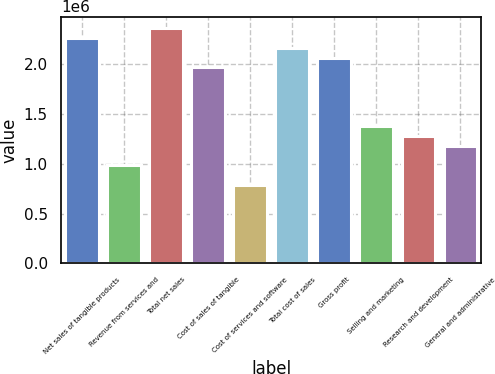<chart> <loc_0><loc_0><loc_500><loc_500><bar_chart><fcel>Net sales of tangible products<fcel>Revenue from services and<fcel>Total net sales<fcel>Cost of sales of tangible<fcel>Cost of services and software<fcel>Total cost of sales<fcel>Gross profit<fcel>Selling and marketing<fcel>Research and development<fcel>General and administrative<nl><fcel>2.26202e+06<fcel>983488<fcel>2.36036e+06<fcel>1.96697e+06<fcel>786791<fcel>2.16367e+06<fcel>2.06532e+06<fcel>1.37688e+06<fcel>1.27853e+06<fcel>1.18018e+06<nl></chart> 